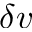<formula> <loc_0><loc_0><loc_500><loc_500>\delta v</formula> 